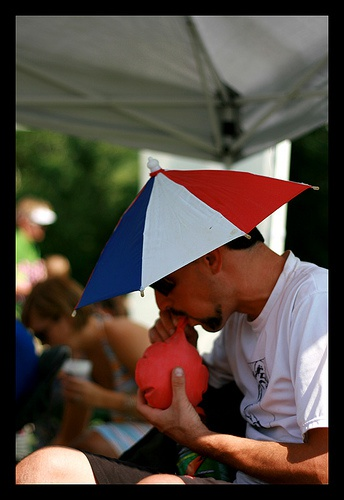Describe the objects in this image and their specific colors. I can see people in black, maroon, darkgray, and gray tones, umbrella in black, brown, navy, and darkgray tones, people in black, maroon, and gray tones, and people in black, salmon, lightgray, and tan tones in this image. 